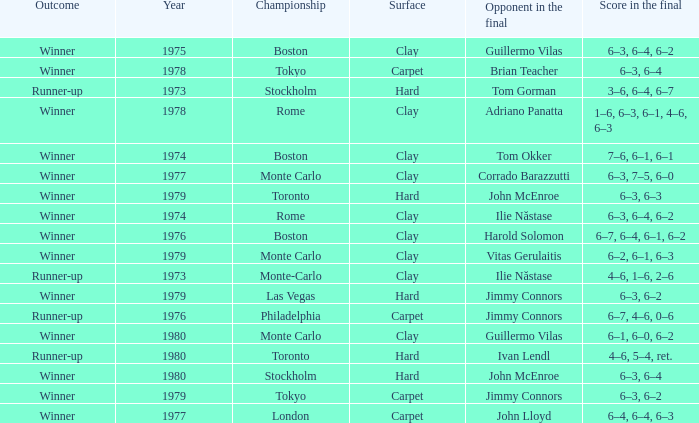Parse the full table. {'header': ['Outcome', 'Year', 'Championship', 'Surface', 'Opponent in the final', 'Score in the final'], 'rows': [['Winner', '1975', 'Boston', 'Clay', 'Guillermo Vilas', '6–3, 6–4, 6–2'], ['Winner', '1978', 'Tokyo', 'Carpet', 'Brian Teacher', '6–3, 6–4'], ['Runner-up', '1973', 'Stockholm', 'Hard', 'Tom Gorman', '3–6, 6–4, 6–7'], ['Winner', '1978', 'Rome', 'Clay', 'Adriano Panatta', '1–6, 6–3, 6–1, 4–6, 6–3'], ['Winner', '1974', 'Boston', 'Clay', 'Tom Okker', '7–6, 6–1, 6–1'], ['Winner', '1977', 'Monte Carlo', 'Clay', 'Corrado Barazzutti', '6–3, 7–5, 6–0'], ['Winner', '1979', 'Toronto', 'Hard', 'John McEnroe', '6–3, 6–3'], ['Winner', '1974', 'Rome', 'Clay', 'Ilie Năstase', '6–3, 6–4, 6–2'], ['Winner', '1976', 'Boston', 'Clay', 'Harold Solomon', '6–7, 6–4, 6–1, 6–2'], ['Winner', '1979', 'Monte Carlo', 'Clay', 'Vitas Gerulaitis', '6–2, 6–1, 6–3'], ['Runner-up', '1973', 'Monte-Carlo', 'Clay', 'Ilie Năstase', '4–6, 1–6, 2–6'], ['Winner', '1979', 'Las Vegas', 'Hard', 'Jimmy Connors', '6–3, 6–2'], ['Runner-up', '1976', 'Philadelphia', 'Carpet', 'Jimmy Connors', '6–7, 4–6, 0–6'], ['Winner', '1980', 'Monte Carlo', 'Clay', 'Guillermo Vilas', '6–1, 6–0, 6–2'], ['Runner-up', '1980', 'Toronto', 'Hard', 'Ivan Lendl', '4–6, 5–4, ret.'], ['Winner', '1980', 'Stockholm', 'Hard', 'John McEnroe', '6–3, 6–4'], ['Winner', '1979', 'Tokyo', 'Carpet', 'Jimmy Connors', '6–3, 6–2'], ['Winner', '1977', 'London', 'Carpet', 'John Lloyd', '6–4, 6–4, 6–3']]} Name the surface for philadelphia Carpet. 